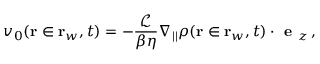Convert formula to latex. <formula><loc_0><loc_0><loc_500><loc_500>v _ { 0 } ( r \in r _ { w } , t ) = - \frac { \mathcal { L } } { \beta \eta } \nabla _ { | | } \rho ( r \in r _ { w } , t ) \cdot e _ { z } \, ,</formula> 